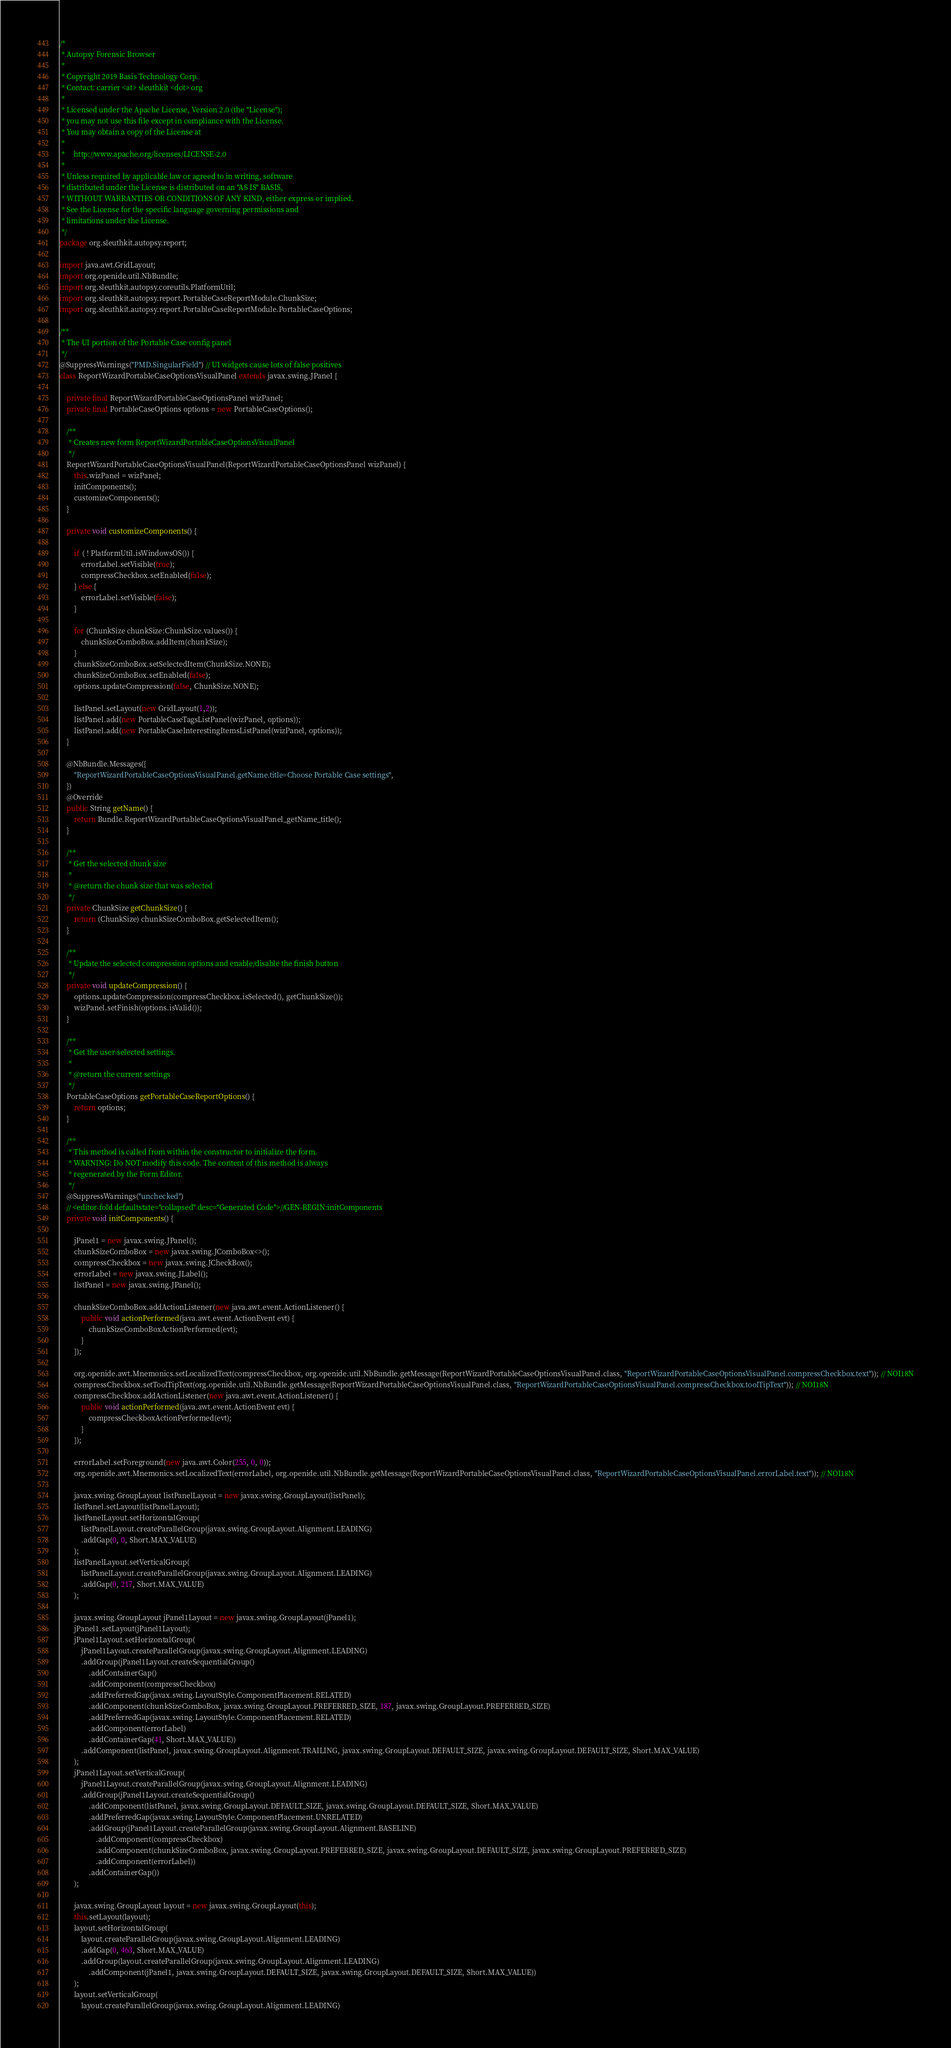<code> <loc_0><loc_0><loc_500><loc_500><_Java_>/*
 * Autopsy Forensic Browser
 *
 * Copyright 2019 Basis Technology Corp.
 * Contact: carrier <at> sleuthkit <dot> org
 *
 * Licensed under the Apache License, Version 2.0 (the "License");
 * you may not use this file except in compliance with the License.
 * You may obtain a copy of the License at
 *
 *     http://www.apache.org/licenses/LICENSE-2.0
 *
 * Unless required by applicable law or agreed to in writing, software
 * distributed under the License is distributed on an "AS IS" BASIS,
 * WITHOUT WARRANTIES OR CONDITIONS OF ANY KIND, either express or implied.
 * See the License for the specific language governing permissions and
 * limitations under the License.
 */
package org.sleuthkit.autopsy.report;

import java.awt.GridLayout;
import org.openide.util.NbBundle;
import org.sleuthkit.autopsy.coreutils.PlatformUtil;
import org.sleuthkit.autopsy.report.PortableCaseReportModule.ChunkSize;
import org.sleuthkit.autopsy.report.PortableCaseReportModule.PortableCaseOptions;

/**
 * The UI portion of the Portable Case config panel
 */
@SuppressWarnings("PMD.SingularField") // UI widgets cause lots of false positives
class ReportWizardPortableCaseOptionsVisualPanel extends javax.swing.JPanel {

    private final ReportWizardPortableCaseOptionsPanel wizPanel;
    private final PortableCaseOptions options = new PortableCaseOptions();
    
    /**
     * Creates new form ReportWizardPortableCaseOptionsVisualPanel
     */
    ReportWizardPortableCaseOptionsVisualPanel(ReportWizardPortableCaseOptionsPanel wizPanel) {
        this.wizPanel = wizPanel;
        initComponents();
        customizeComponents();
    }
    
    private void customizeComponents() {
        
        if ( ! PlatformUtil.isWindowsOS()) {
            errorLabel.setVisible(true);
            compressCheckbox.setEnabled(false);
        } else {
            errorLabel.setVisible(false);
        }
        
        for (ChunkSize chunkSize:ChunkSize.values()) {
            chunkSizeComboBox.addItem(chunkSize);
        }
        chunkSizeComboBox.setSelectedItem(ChunkSize.NONE);
        chunkSizeComboBox.setEnabled(false);
        options.updateCompression(false, ChunkSize.NONE);        
        
        listPanel.setLayout(new GridLayout(1,2));
        listPanel.add(new PortableCaseTagsListPanel(wizPanel, options));
        listPanel.add(new PortableCaseInterestingItemsListPanel(wizPanel, options));
    }
    
    @NbBundle.Messages({
        "ReportWizardPortableCaseOptionsVisualPanel.getName.title=Choose Portable Case settings",  
    })  
    @Override
    public String getName() {
        return Bundle.ReportWizardPortableCaseOptionsVisualPanel_getName_title();
    }
    
    /**
     * Get the selected chunk size
     * 
     * @return the chunk size that was selected
     */
    private ChunkSize getChunkSize() {
        return (ChunkSize) chunkSizeComboBox.getSelectedItem();
    }
    
    /**
     * Update the selected compression options and enable/disable the finish button
     */
    private void updateCompression() {
        options.updateCompression(compressCheckbox.isSelected(), getChunkSize());
        wizPanel.setFinish(options.isValid());
    }
    
    /**
     * Get the user-selected settings.
     *
     * @return the current settings
     */
    PortableCaseOptions getPortableCaseReportOptions() {
        return options;
    }    

    /**
     * This method is called from within the constructor to initialize the form.
     * WARNING: Do NOT modify this code. The content of this method is always
     * regenerated by the Form Editor.
     */
    @SuppressWarnings("unchecked")
    // <editor-fold defaultstate="collapsed" desc="Generated Code">//GEN-BEGIN:initComponents
    private void initComponents() {

        jPanel1 = new javax.swing.JPanel();
        chunkSizeComboBox = new javax.swing.JComboBox<>();
        compressCheckbox = new javax.swing.JCheckBox();
        errorLabel = new javax.swing.JLabel();
        listPanel = new javax.swing.JPanel();

        chunkSizeComboBox.addActionListener(new java.awt.event.ActionListener() {
            public void actionPerformed(java.awt.event.ActionEvent evt) {
                chunkSizeComboBoxActionPerformed(evt);
            }
        });

        org.openide.awt.Mnemonics.setLocalizedText(compressCheckbox, org.openide.util.NbBundle.getMessage(ReportWizardPortableCaseOptionsVisualPanel.class, "ReportWizardPortableCaseOptionsVisualPanel.compressCheckbox.text")); // NOI18N
        compressCheckbox.setToolTipText(org.openide.util.NbBundle.getMessage(ReportWizardPortableCaseOptionsVisualPanel.class, "ReportWizardPortableCaseOptionsVisualPanel.compressCheckbox.toolTipText")); // NOI18N
        compressCheckbox.addActionListener(new java.awt.event.ActionListener() {
            public void actionPerformed(java.awt.event.ActionEvent evt) {
                compressCheckboxActionPerformed(evt);
            }
        });

        errorLabel.setForeground(new java.awt.Color(255, 0, 0));
        org.openide.awt.Mnemonics.setLocalizedText(errorLabel, org.openide.util.NbBundle.getMessage(ReportWizardPortableCaseOptionsVisualPanel.class, "ReportWizardPortableCaseOptionsVisualPanel.errorLabel.text")); // NOI18N

        javax.swing.GroupLayout listPanelLayout = new javax.swing.GroupLayout(listPanel);
        listPanel.setLayout(listPanelLayout);
        listPanelLayout.setHorizontalGroup(
            listPanelLayout.createParallelGroup(javax.swing.GroupLayout.Alignment.LEADING)
            .addGap(0, 0, Short.MAX_VALUE)
        );
        listPanelLayout.setVerticalGroup(
            listPanelLayout.createParallelGroup(javax.swing.GroupLayout.Alignment.LEADING)
            .addGap(0, 217, Short.MAX_VALUE)
        );

        javax.swing.GroupLayout jPanel1Layout = new javax.swing.GroupLayout(jPanel1);
        jPanel1.setLayout(jPanel1Layout);
        jPanel1Layout.setHorizontalGroup(
            jPanel1Layout.createParallelGroup(javax.swing.GroupLayout.Alignment.LEADING)
            .addGroup(jPanel1Layout.createSequentialGroup()
                .addContainerGap()
                .addComponent(compressCheckbox)
                .addPreferredGap(javax.swing.LayoutStyle.ComponentPlacement.RELATED)
                .addComponent(chunkSizeComboBox, javax.swing.GroupLayout.PREFERRED_SIZE, 187, javax.swing.GroupLayout.PREFERRED_SIZE)
                .addPreferredGap(javax.swing.LayoutStyle.ComponentPlacement.RELATED)
                .addComponent(errorLabel)
                .addContainerGap(41, Short.MAX_VALUE))
            .addComponent(listPanel, javax.swing.GroupLayout.Alignment.TRAILING, javax.swing.GroupLayout.DEFAULT_SIZE, javax.swing.GroupLayout.DEFAULT_SIZE, Short.MAX_VALUE)
        );
        jPanel1Layout.setVerticalGroup(
            jPanel1Layout.createParallelGroup(javax.swing.GroupLayout.Alignment.LEADING)
            .addGroup(jPanel1Layout.createSequentialGroup()
                .addComponent(listPanel, javax.swing.GroupLayout.DEFAULT_SIZE, javax.swing.GroupLayout.DEFAULT_SIZE, Short.MAX_VALUE)
                .addPreferredGap(javax.swing.LayoutStyle.ComponentPlacement.UNRELATED)
                .addGroup(jPanel1Layout.createParallelGroup(javax.swing.GroupLayout.Alignment.BASELINE)
                    .addComponent(compressCheckbox)
                    .addComponent(chunkSizeComboBox, javax.swing.GroupLayout.PREFERRED_SIZE, javax.swing.GroupLayout.DEFAULT_SIZE, javax.swing.GroupLayout.PREFERRED_SIZE)
                    .addComponent(errorLabel))
                .addContainerGap())
        );

        javax.swing.GroupLayout layout = new javax.swing.GroupLayout(this);
        this.setLayout(layout);
        layout.setHorizontalGroup(
            layout.createParallelGroup(javax.swing.GroupLayout.Alignment.LEADING)
            .addGap(0, 463, Short.MAX_VALUE)
            .addGroup(layout.createParallelGroup(javax.swing.GroupLayout.Alignment.LEADING)
                .addComponent(jPanel1, javax.swing.GroupLayout.DEFAULT_SIZE, javax.swing.GroupLayout.DEFAULT_SIZE, Short.MAX_VALUE))
        );
        layout.setVerticalGroup(
            layout.createParallelGroup(javax.swing.GroupLayout.Alignment.LEADING)</code> 